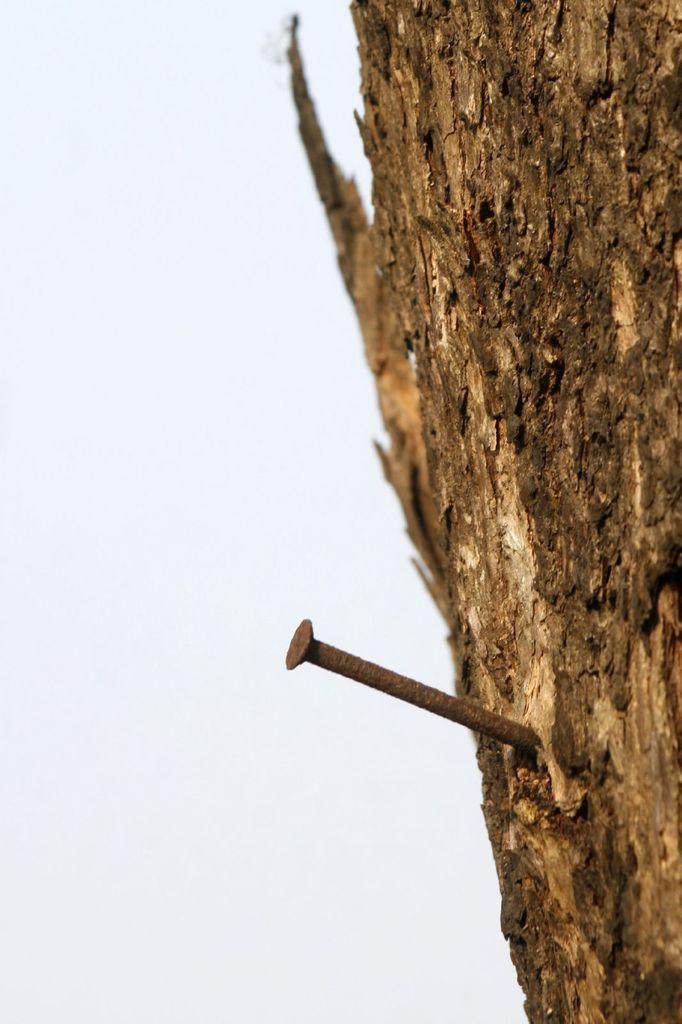Please provide a concise description of this image. There is a brown color nail, which is inserted in the wood of a tree. In the background, there is a sky. 